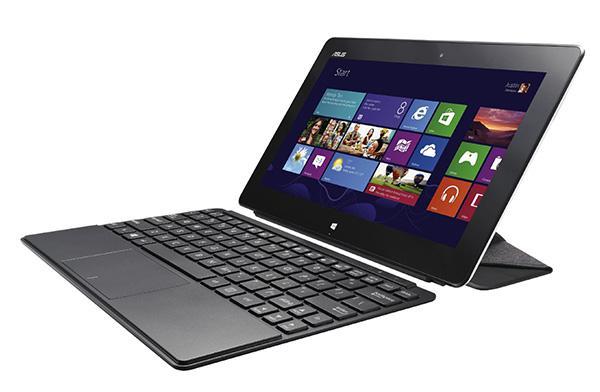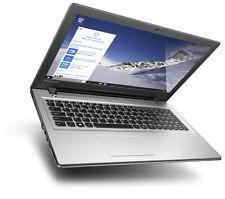The first image is the image on the left, the second image is the image on the right. For the images displayed, is the sentence "The laptop on the left is facing to the left." factually correct? Answer yes or no. Yes. The first image is the image on the left, the second image is the image on the right. Given the left and right images, does the statement "In at least one image there is a laptop with a blue screen and a sliver base near the keyboard." hold true? Answer yes or no. Yes. 